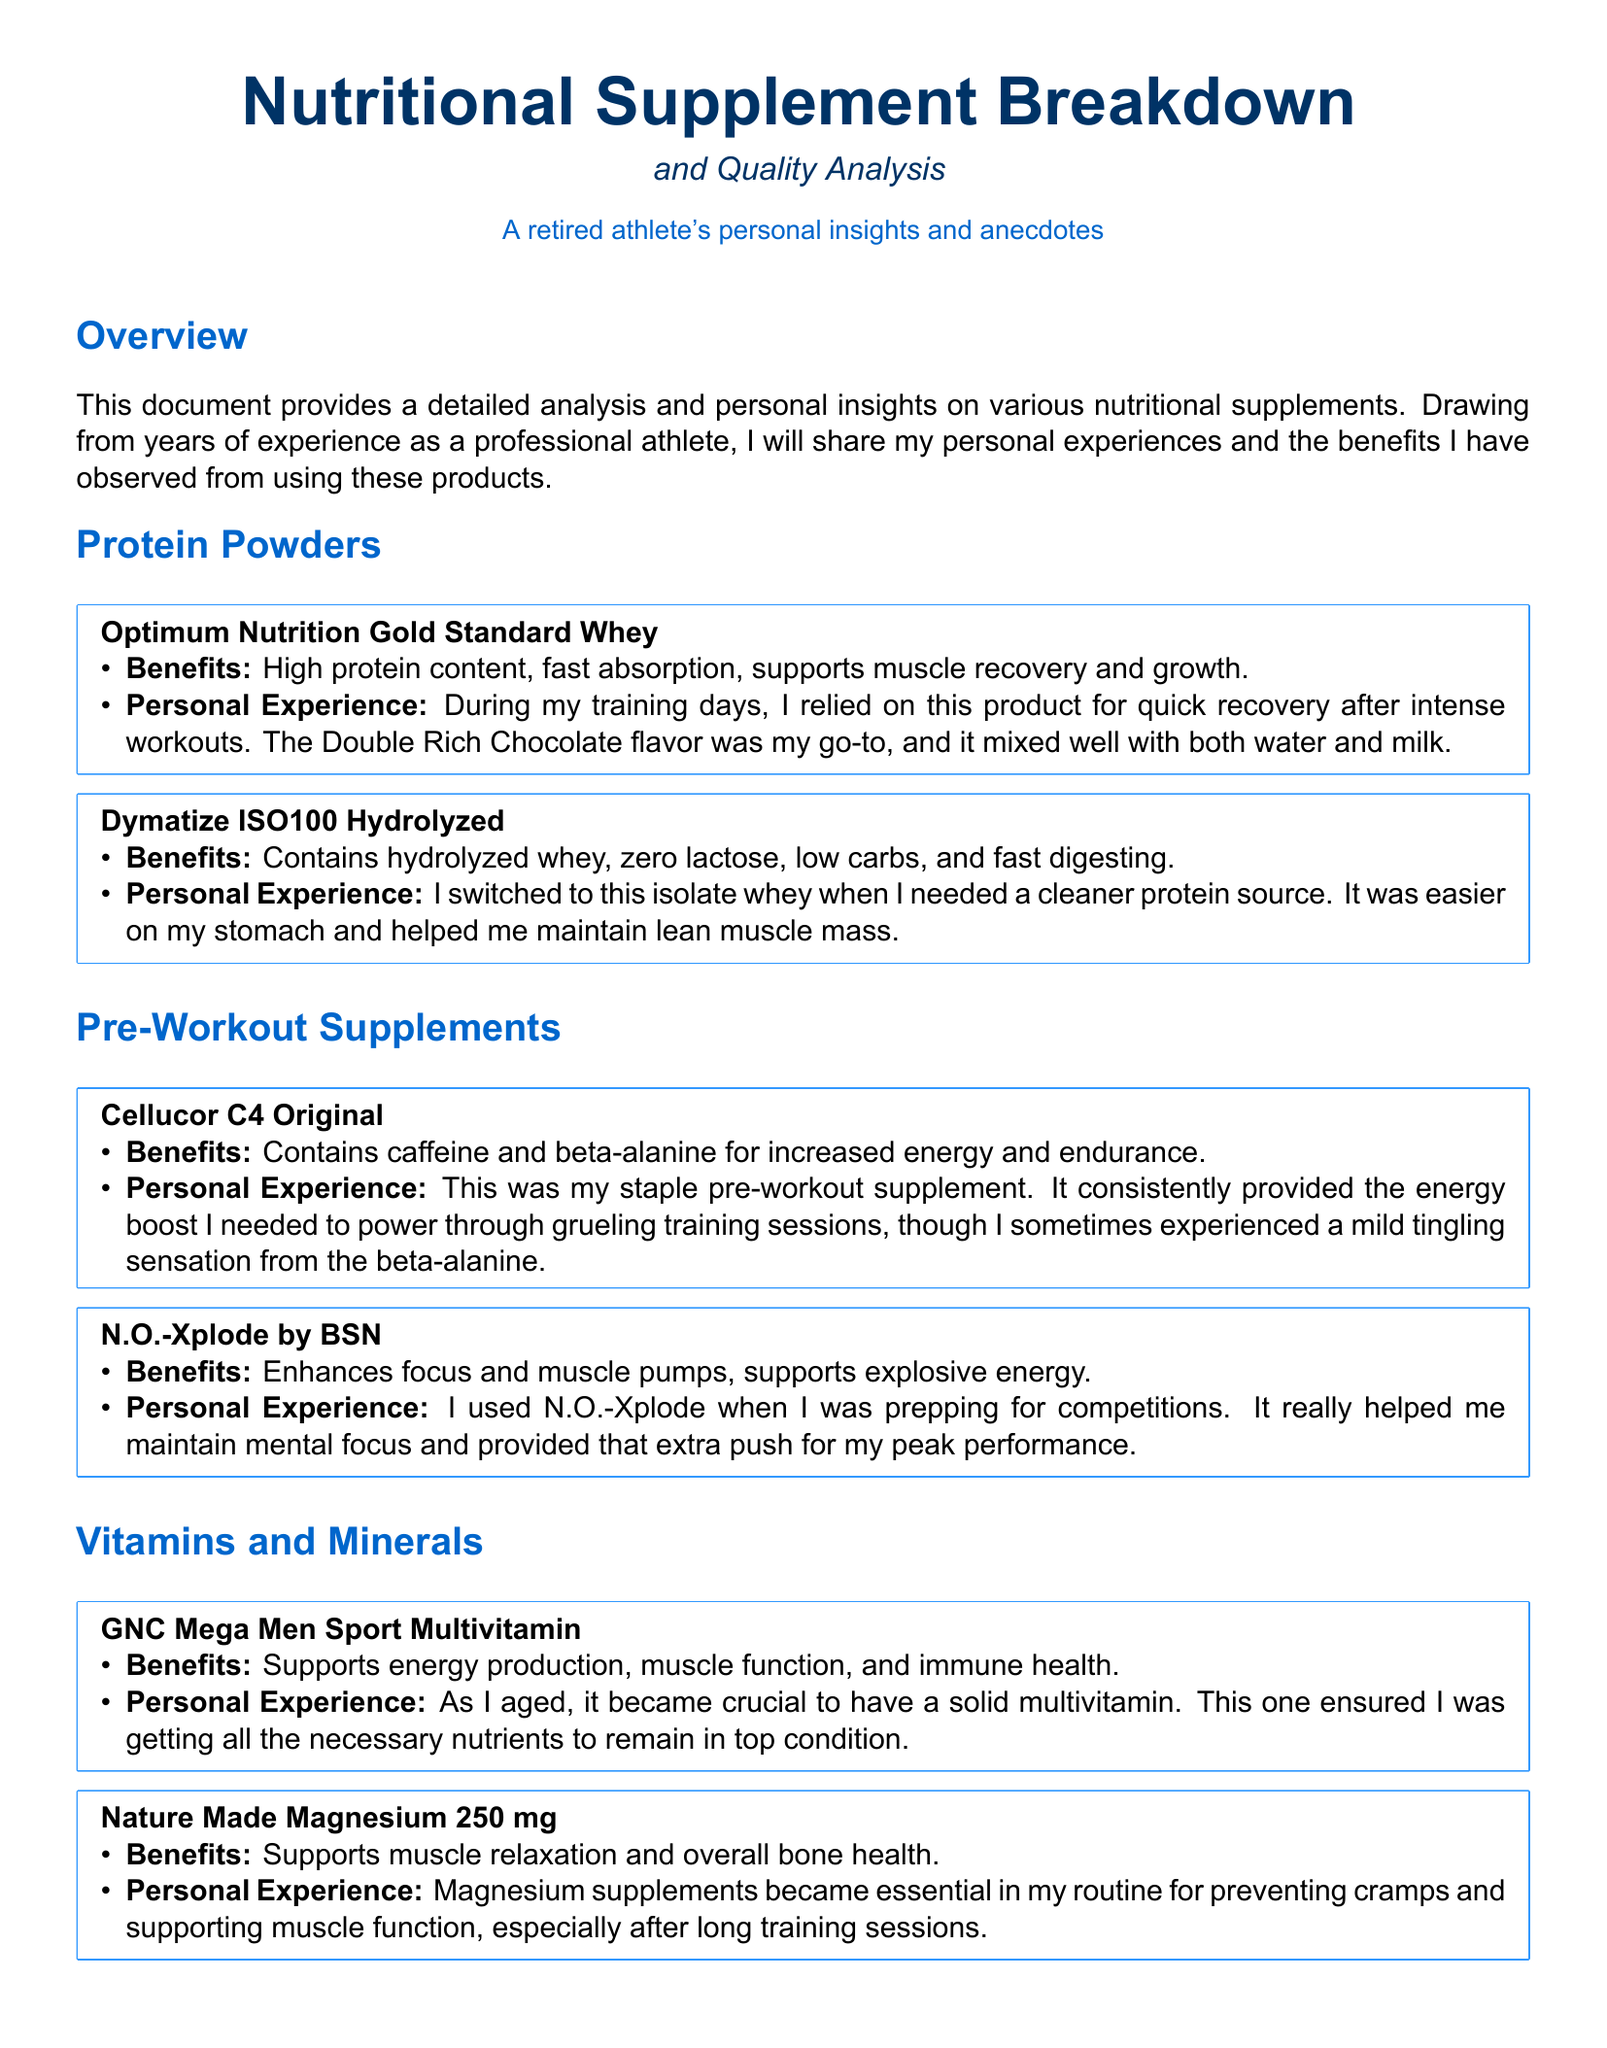What are the benefits of Optimum Nutrition Gold Standard Whey? The benefits listed in the document include high protein content, fast absorption, and support for muscle recovery and growth.
Answer: High protein content, fast absorption, supports muscle recovery and growth What flavor of Optimum Nutrition Gold Standard Whey did the author prefer? In the personal experience section for this product, the author mentions that Double Rich Chocolate was their go-to flavor.
Answer: Double Rich Chocolate What key ingredient does Dymatize ISO100 Hydrolyzed contain? The document specifies that Dymatize ISO100 Hydrolyzed contains hydrolyzed whey.
Answer: Hydrolyzed whey Which pre-workout product is mentioned as a staple for the author? The author states that Cellucor C4 Original was their staple pre-workout supplement due to its consistent energy boost.
Answer: Cellucor C4 Original What was the essential purpose of magnesium supplements for the author? The document notes that magnesium supplements became essential in the author's routine for preventing cramps and supporting muscle function.
Answer: Preventing cramps and supporting muscle function Which recovery supplement did the author find particularly helpful during back-to-back training days? According to the document, Xtend Original BCAA was found particularly helpful for muscle recovery during intense training periods.
Answer: Xtend Original BCAA How does the author describe their experience with N.O.-Xplode by BSN? The author notes that N.O.-Xplode helped maintain mental focus and provided an extra push for peak performance during competition prep.
Answer: Helped maintain mental focus and provided an extra push for peak performance What type of nutrients does GNC Mega Men Sport Multivitamin support? The document lists energy production, muscle function, and immune health as the supported aspects of this multivitamin.
Answer: Energy production, muscle function, immune health What does glutamine support according to the author’s experience? The author includes that glutamine enhances recovery and supports muscle protein synthesis and immune function.
Answer: Enhances recovery, supports muscle protein synthesis, immune function 